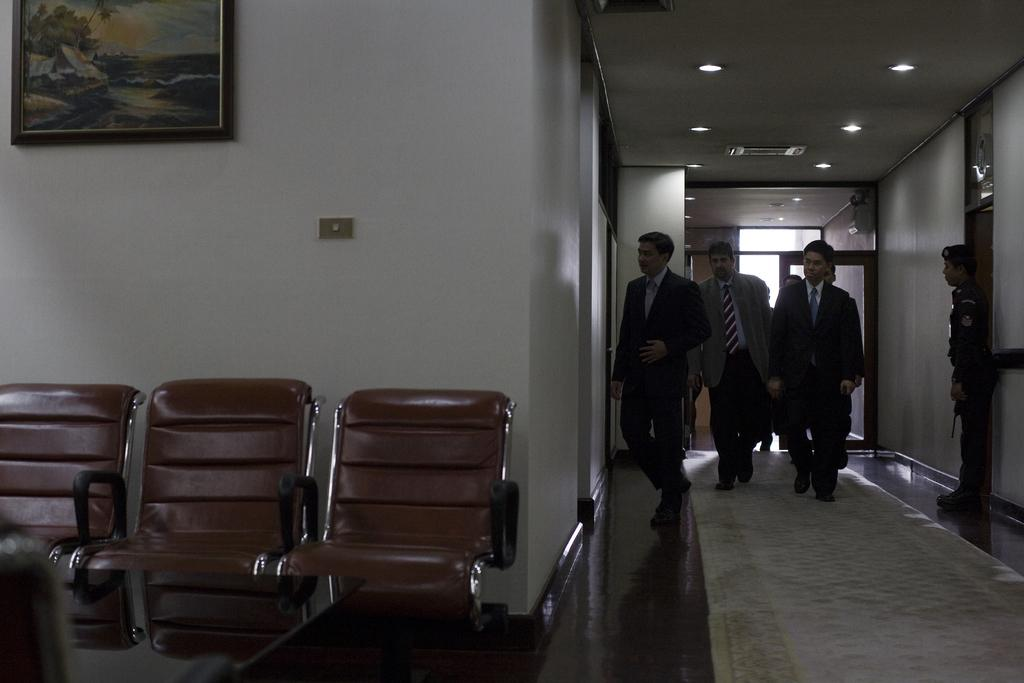What are the people in the image doing? The people in the image are walking. What objects are present in the image that are not being used? There are empty chairs in the image. What can be seen in the background of the image? There is a wall, a photo frame, and lights on the ceiling in the background of the image. What type of produce is being harvested by the people in the image? There is no produce or harvesting activity depicted in the image; it shows people walking and empty chairs. 